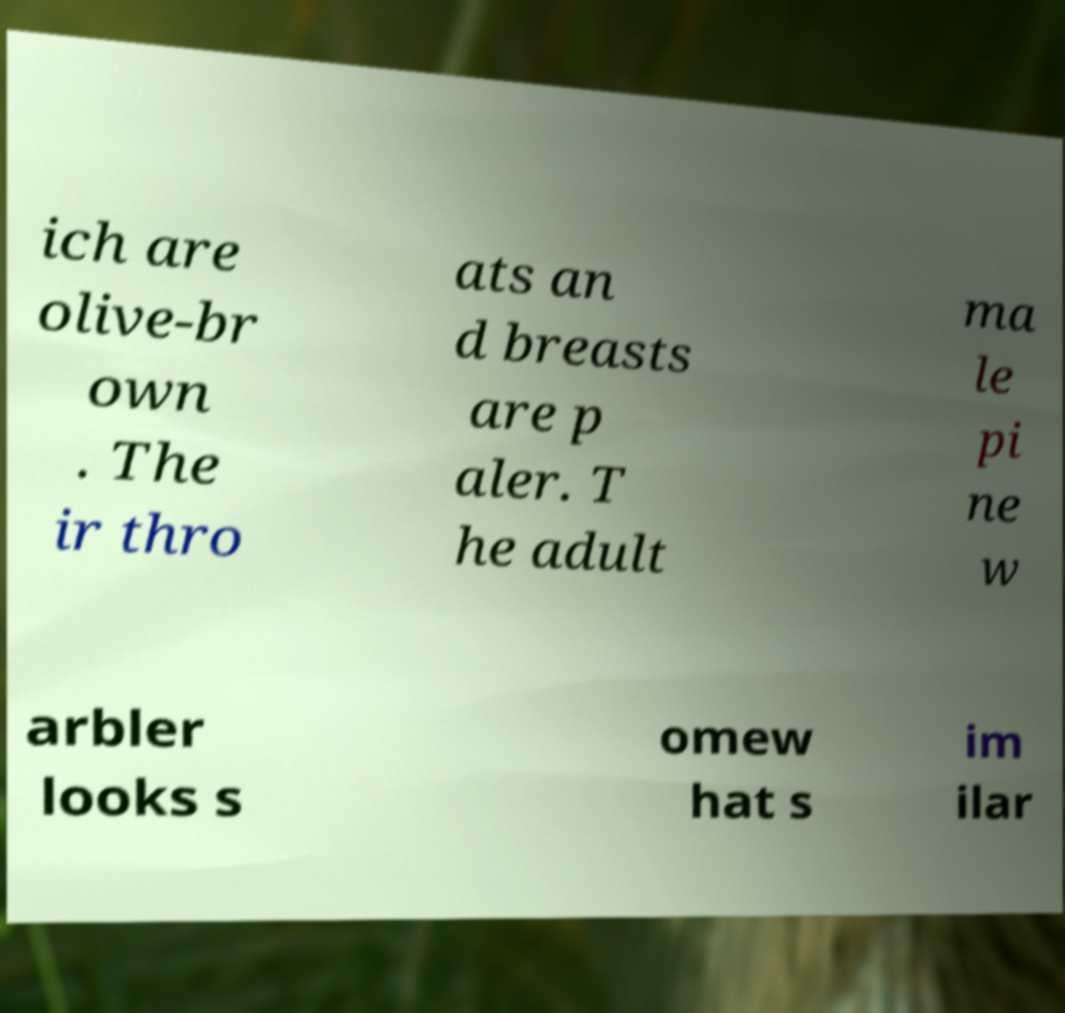Please read and relay the text visible in this image. What does it say? ich are olive-br own . The ir thro ats an d breasts are p aler. T he adult ma le pi ne w arbler looks s omew hat s im ilar 